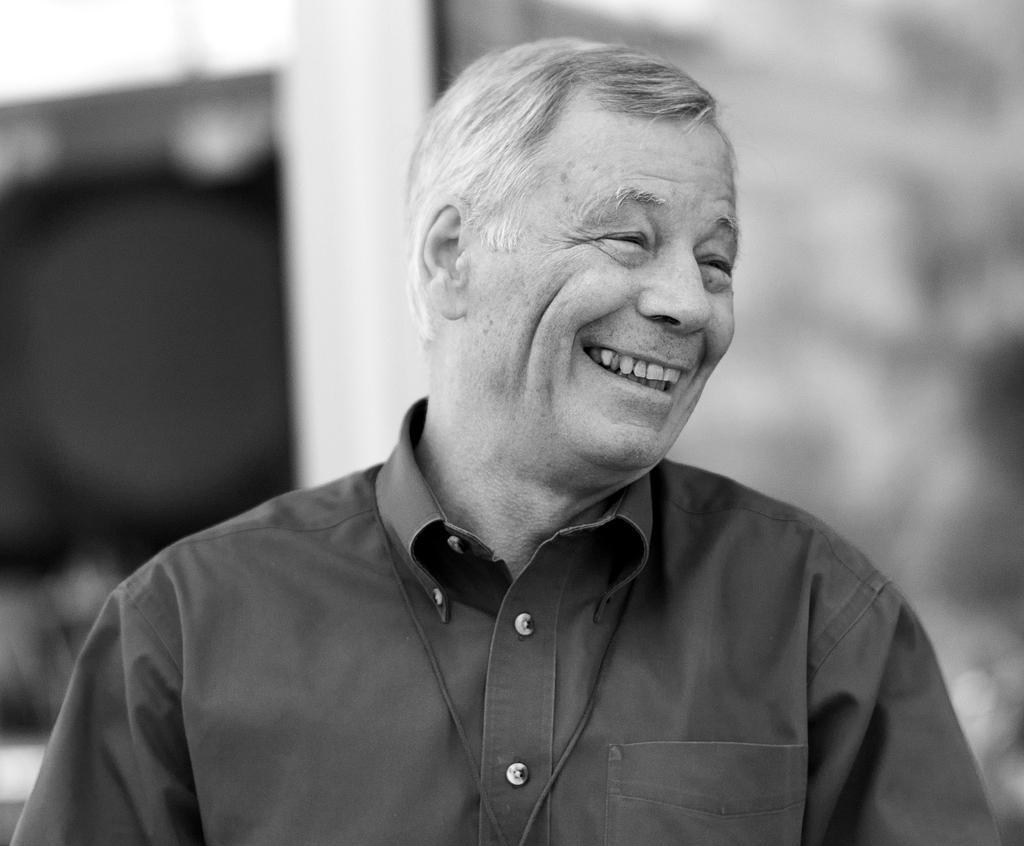Could you give a brief overview of what you see in this image? Here this is a black and white image, in which we can see a man present over a place and he is smiling. 